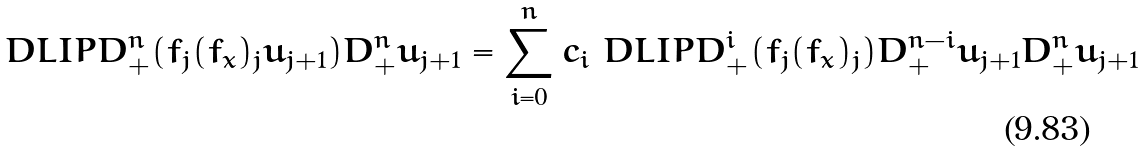<formula> <loc_0><loc_0><loc_500><loc_500>\ D L I P { D _ { + } ^ { n } ( f _ { j } ( f _ { x } ) _ { j } u _ { j + 1 } ) } { D _ { + } ^ { n } u _ { j + 1 } } = \sum _ { i = 0 } ^ { n } c _ { i } \ D L I P { D _ { + } ^ { i } ( f _ { j } ( f _ { x } ) _ { j } ) D _ { + } ^ { n - i } u _ { j + 1 } } { D _ { + } ^ { n } u _ { j + 1 } }</formula> 